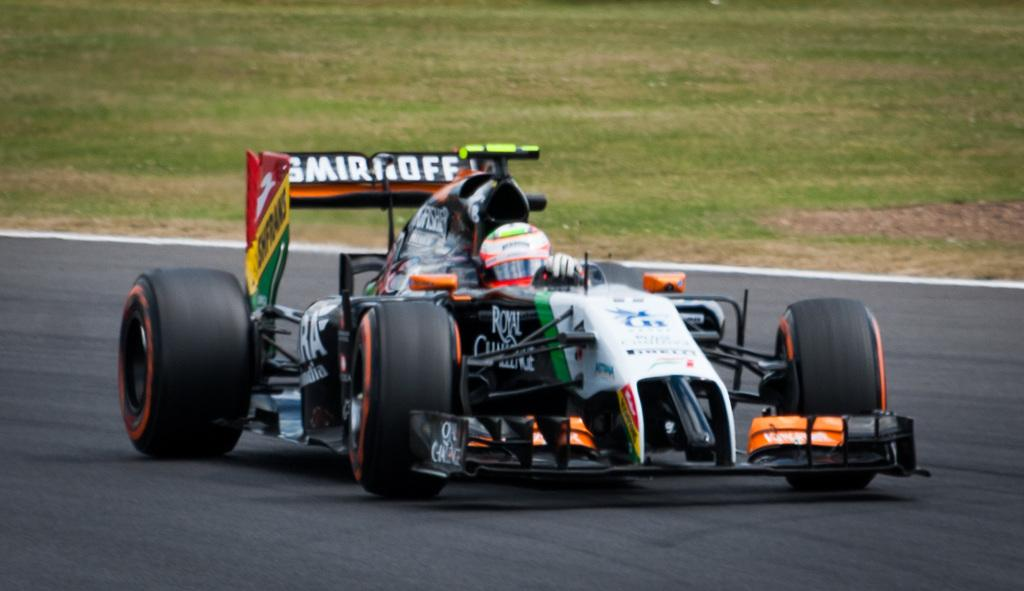What is the person in the image doing? The person is driving a car in the image. What safety precaution is the person taking while driving? The person is wearing a helmet. What type of environment can be seen in the background of the image? There is grass visible in the background of the image. Can you see a tiger swimming in the background of the image? No, there is no tiger or any body of water present in the image. 